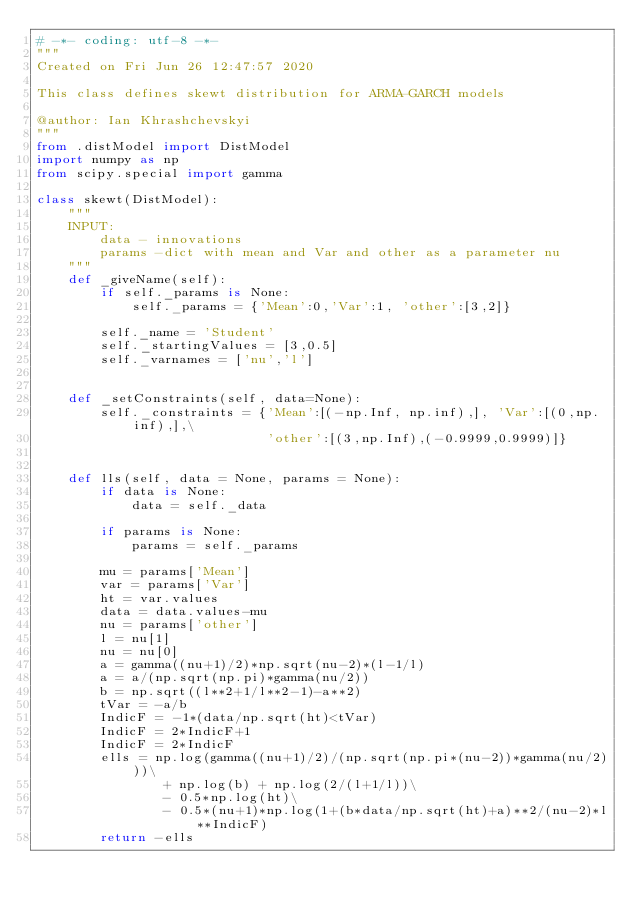<code> <loc_0><loc_0><loc_500><loc_500><_Python_># -*- coding: utf-8 -*-
"""
Created on Fri Jun 26 12:47:57 2020

This class defines skewt distribution for ARMA-GARCH models

@author: Ian Khrashchevskyi
"""
from .distModel import DistModel
import numpy as np
from scipy.special import gamma

class skewt(DistModel):
    """
    INPUT:
        data - innovations
        params -dict with mean and Var and other as a parameter nu
    """
    def _giveName(self):
        if self._params is None:
            self._params = {'Mean':0,'Var':1, 'other':[3,2]}
        
        self._name = 'Student'
        self._startingValues = [3,0.5]
        self._varnames = ['nu','l']
    
    
    def _setConstraints(self, data=None):
        self._constraints = {'Mean':[(-np.Inf, np.inf),], 'Var':[(0,np.inf),],\
                             'other':[(3,np.Inf),(-0.9999,0.9999)]}
    
    
    def lls(self, data = None, params = None):
        if data is None:
            data = self._data
            
        if params is None:
            params = self._params
        
        mu = params['Mean']
        var = params['Var']
        ht = var.values
        data = data.values-mu
        nu = params['other']
        l = nu[1]
        nu = nu[0]
        a = gamma((nu+1)/2)*np.sqrt(nu-2)*(l-1/l)
        a = a/(np.sqrt(np.pi)*gamma(nu/2))
        b = np.sqrt((l**2+1/l**2-1)-a**2)
        tVar = -a/b
        IndicF = -1*(data/np.sqrt(ht)<tVar)
        IndicF = 2*IndicF+1
        IndicF = 2*IndicF
        ells = np.log(gamma((nu+1)/2)/(np.sqrt(np.pi*(nu-2))*gamma(nu/2)))\
                + np.log(b) + np.log(2/(l+1/l))\
                - 0.5*np.log(ht)\
                - 0.5*(nu+1)*np.log(1+(b*data/np.sqrt(ht)+a)**2/(nu-2)*l**IndicF)  
        return -ells</code> 